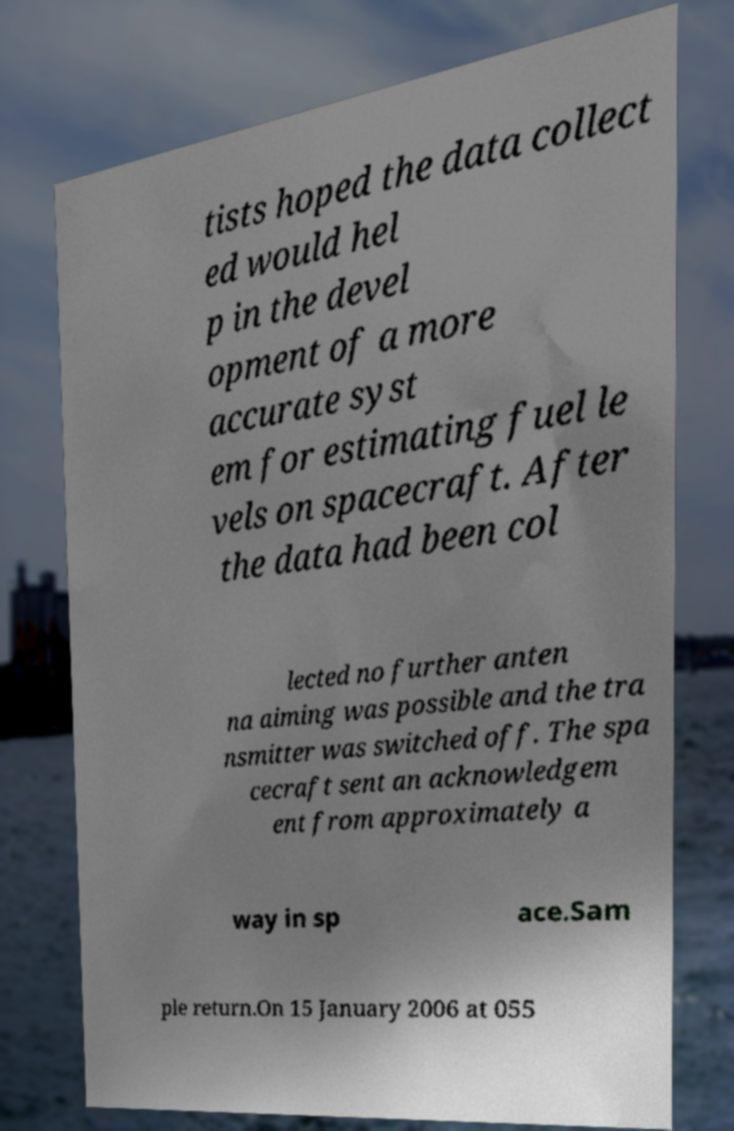Could you extract and type out the text from this image? tists hoped the data collect ed would hel p in the devel opment of a more accurate syst em for estimating fuel le vels on spacecraft. After the data had been col lected no further anten na aiming was possible and the tra nsmitter was switched off. The spa cecraft sent an acknowledgem ent from approximately a way in sp ace.Sam ple return.On 15 January 2006 at 055 